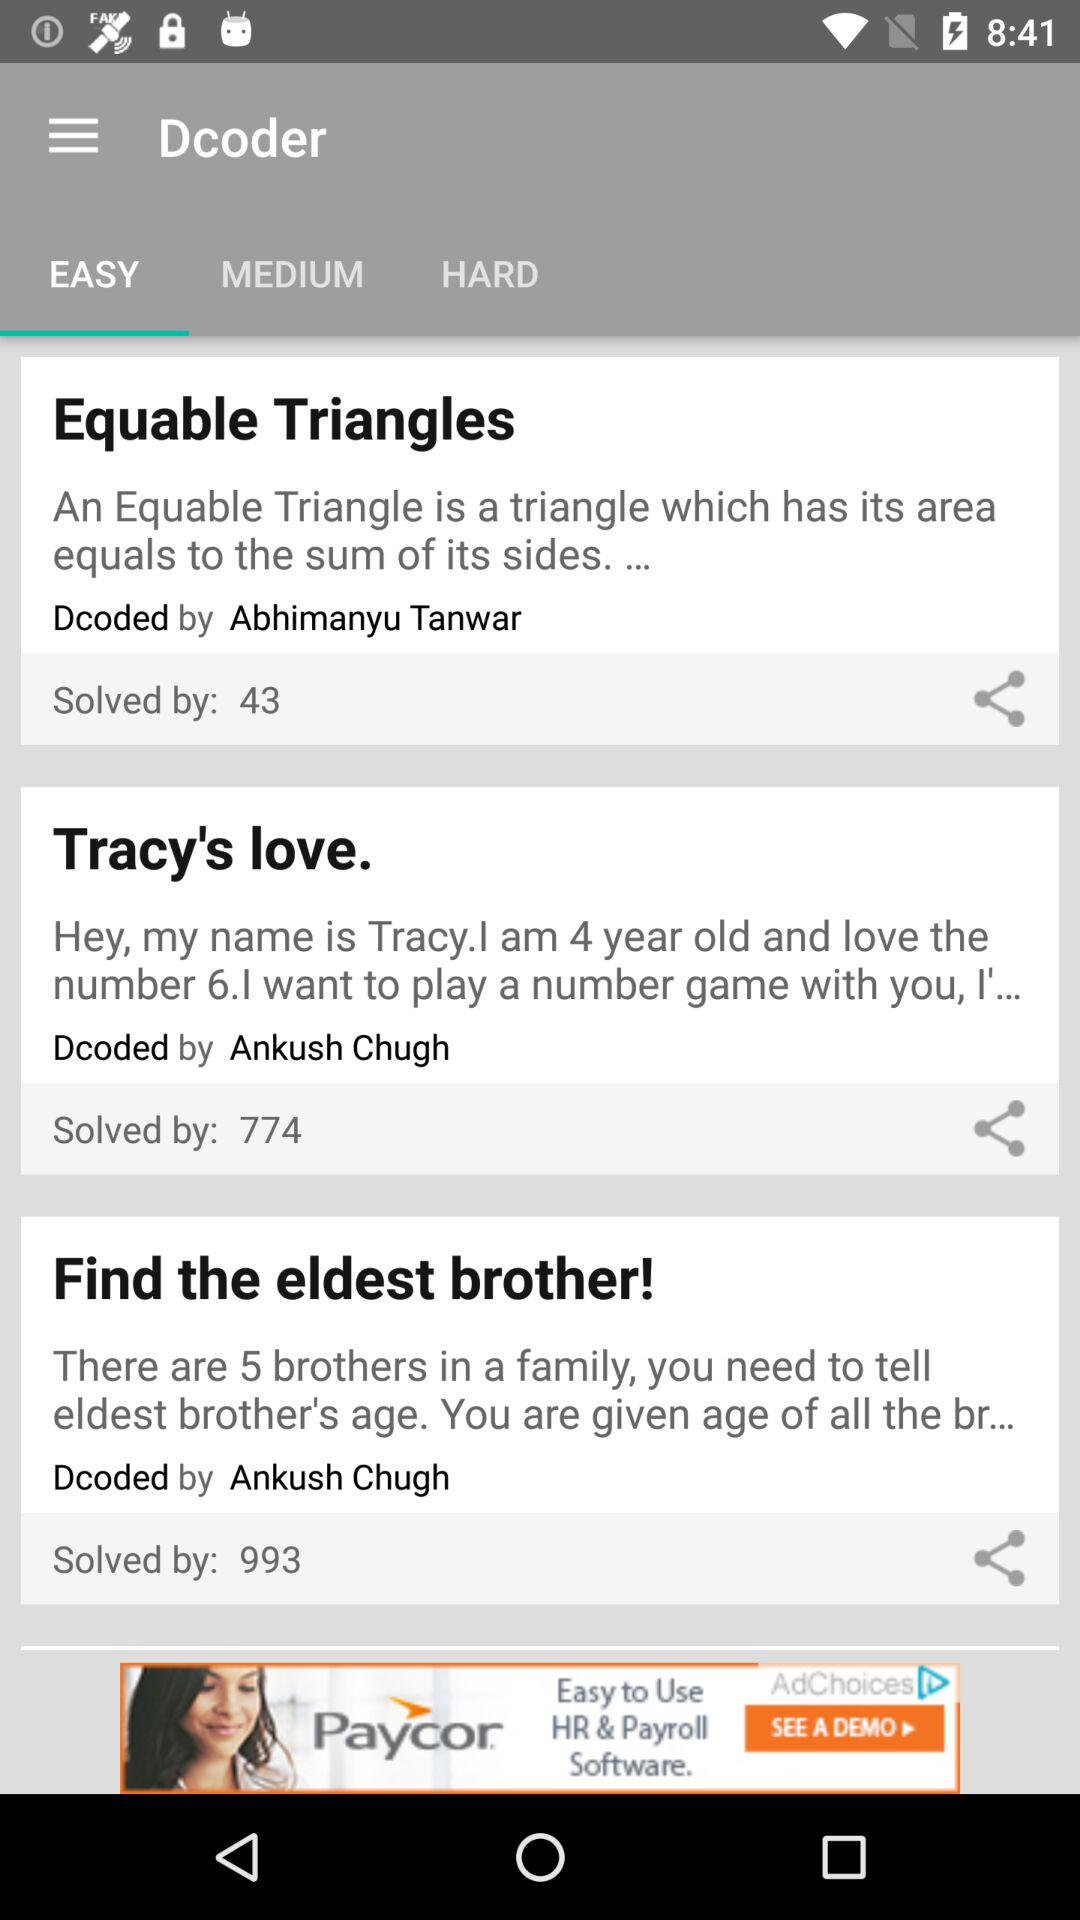How many problems are there in total?
Answer the question using a single word or phrase. 3 